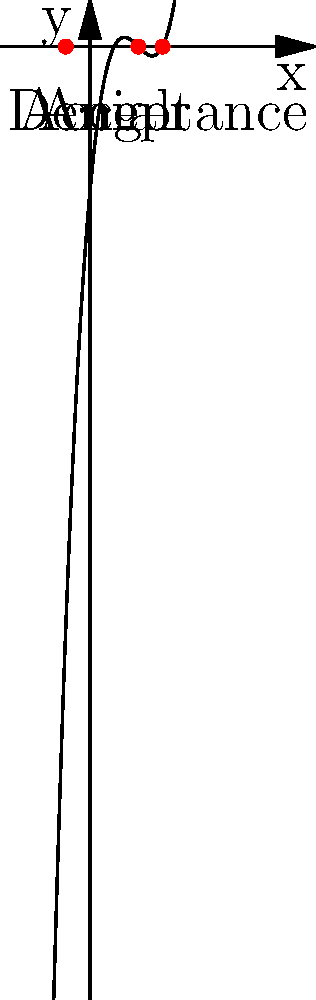A polynomial function $f(x) = x^3 - 6x^2 + 11x - 6$ represents the stages of healing after trauma. The roots of this equation symbolize key turning points in the healing process. Find these roots and interpret their meaning in the context of overcoming grief and achieving forgiveness. To find the roots of the polynomial $f(x) = x^3 - 6x^2 + 11x - 6$, we need to factor it:

1) First, let's try to guess one root. We can see that $f(2) = 2^3 - 6(2^2) + 11(2) - 6 = 8 - 24 + 22 - 6 = 0$
   So, $(x-2)$ is a factor.

2) We can divide the polynomial by $(x-2)$:
   $x^3 - 6x^2 + 11x - 6 = (x-2)(x^2 - 4x + 3)$

3) Now we need to factor $x^2 - 4x + 3$:
   $x^2 - 4x + 3 = (x-3)(x-1)$

4) Therefore, the fully factored polynomial is:
   $f(x) = (x-2)(x-3)(x-1)$

5) The roots are $x = 2$, $x = 3$, and $x = 1$

Interpreting these roots in the context of healing:
- $x = 1$ represents the initial stage of denial
- $x = 2$ represents the stage of anger or grief
- $x = 3$ represents the final stage of acceptance and forgiveness

This progression aligns with common stages of grief and healing, showing a path from initial shock through difficult emotions to eventual acceptance and forgiveness.
Answer: Roots: 1 (denial), 2 (anger), 3 (acceptance) 